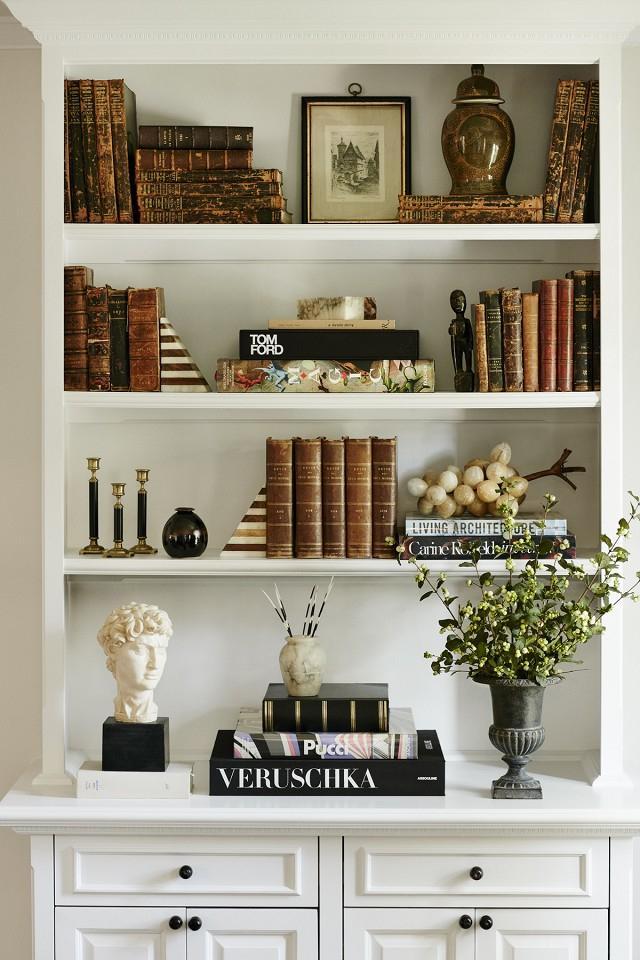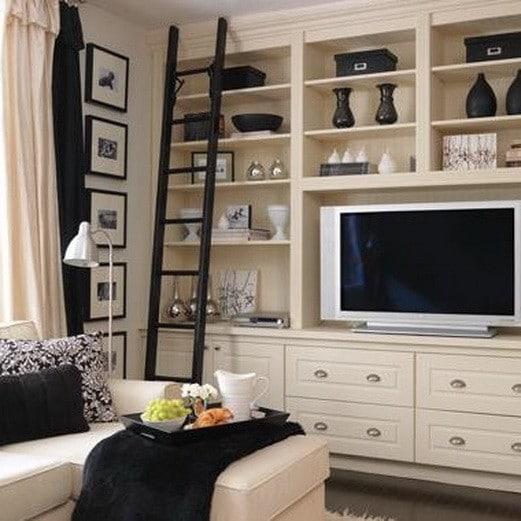The first image is the image on the left, the second image is the image on the right. Assess this claim about the two images: "In one image, floor to ceiling shelving units topped with crown molding flank a fire place and mantle.". Correct or not? Answer yes or no. No. 